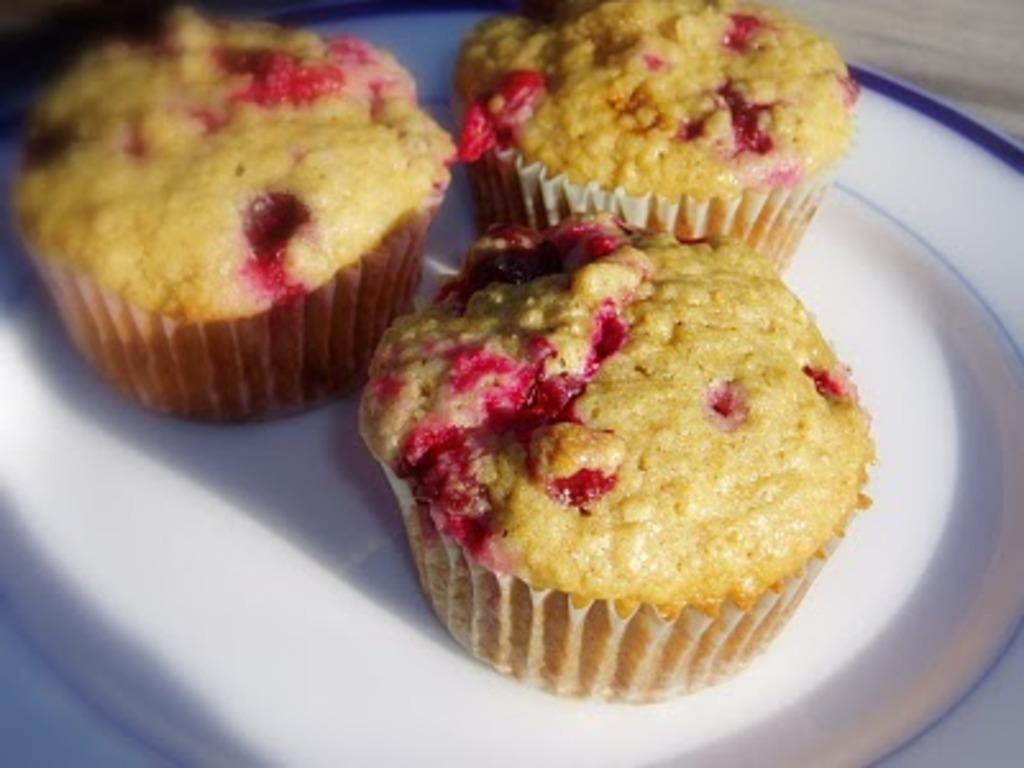What is on the plate that is visible in the image? The plate contains cupcakes. What is the plate placed on in the image? The plate is placed on a surface. What type of branch can be seen growing out of the cupcakes in the image? There is no branch growing out of the cupcakes in the image; the plate contains cupcakes without any additional elements. 